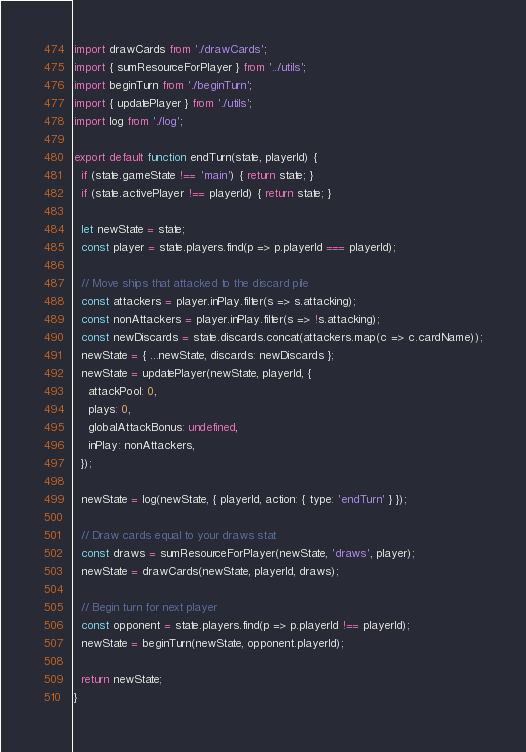<code> <loc_0><loc_0><loc_500><loc_500><_JavaScript_>
import drawCards from './drawCards';
import { sumResourceForPlayer } from '../utils';
import beginTurn from './beginTurn';
import { updatePlayer } from './utils';
import log from './log';

export default function endTurn(state, playerId) {
  if (state.gameState !== 'main') { return state; }
  if (state.activePlayer !== playerId) { return state; }

  let newState = state;
  const player = state.players.find(p => p.playerId === playerId);

  // Move ships that attacked to the discard pile
  const attackers = player.inPlay.filter(s => s.attacking);
  const nonAttackers = player.inPlay.filter(s => !s.attacking);
  const newDiscards = state.discards.concat(attackers.map(c => c.cardName));
  newState = { ...newState, discards: newDiscards };
  newState = updatePlayer(newState, playerId, {
    attackPool: 0,
    plays: 0,
    globalAttackBonus: undefined,
    inPlay: nonAttackers,
  });

  newState = log(newState, { playerId, action: { type: 'endTurn' } });

  // Draw cards equal to your draws stat
  const draws = sumResourceForPlayer(newState, 'draws', player);
  newState = drawCards(newState, playerId, draws);

  // Begin turn for next player
  const opponent = state.players.find(p => p.playerId !== playerId);
  newState = beginTurn(newState, opponent.playerId);

  return newState;
}
</code> 